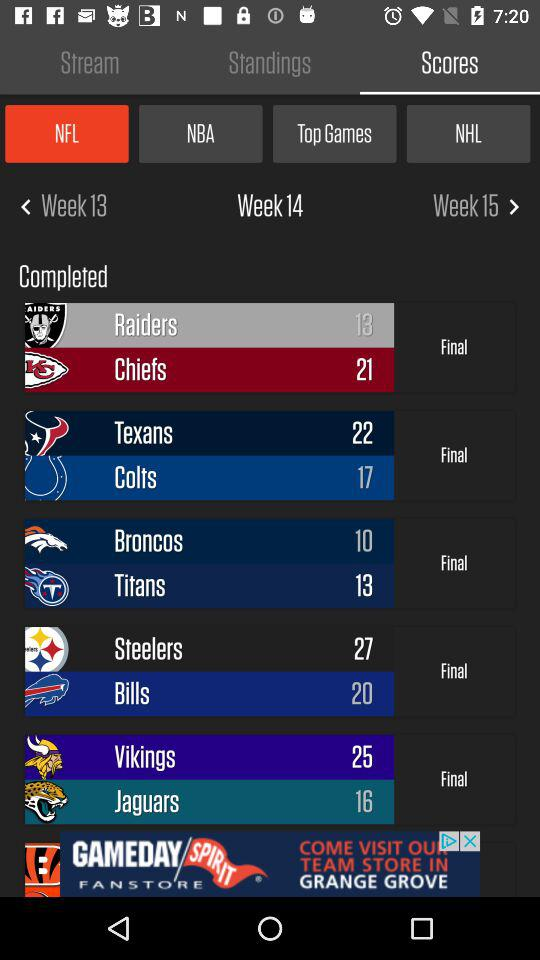What is the score of "Chiefs"? The score of "Chiefs" is 21. 